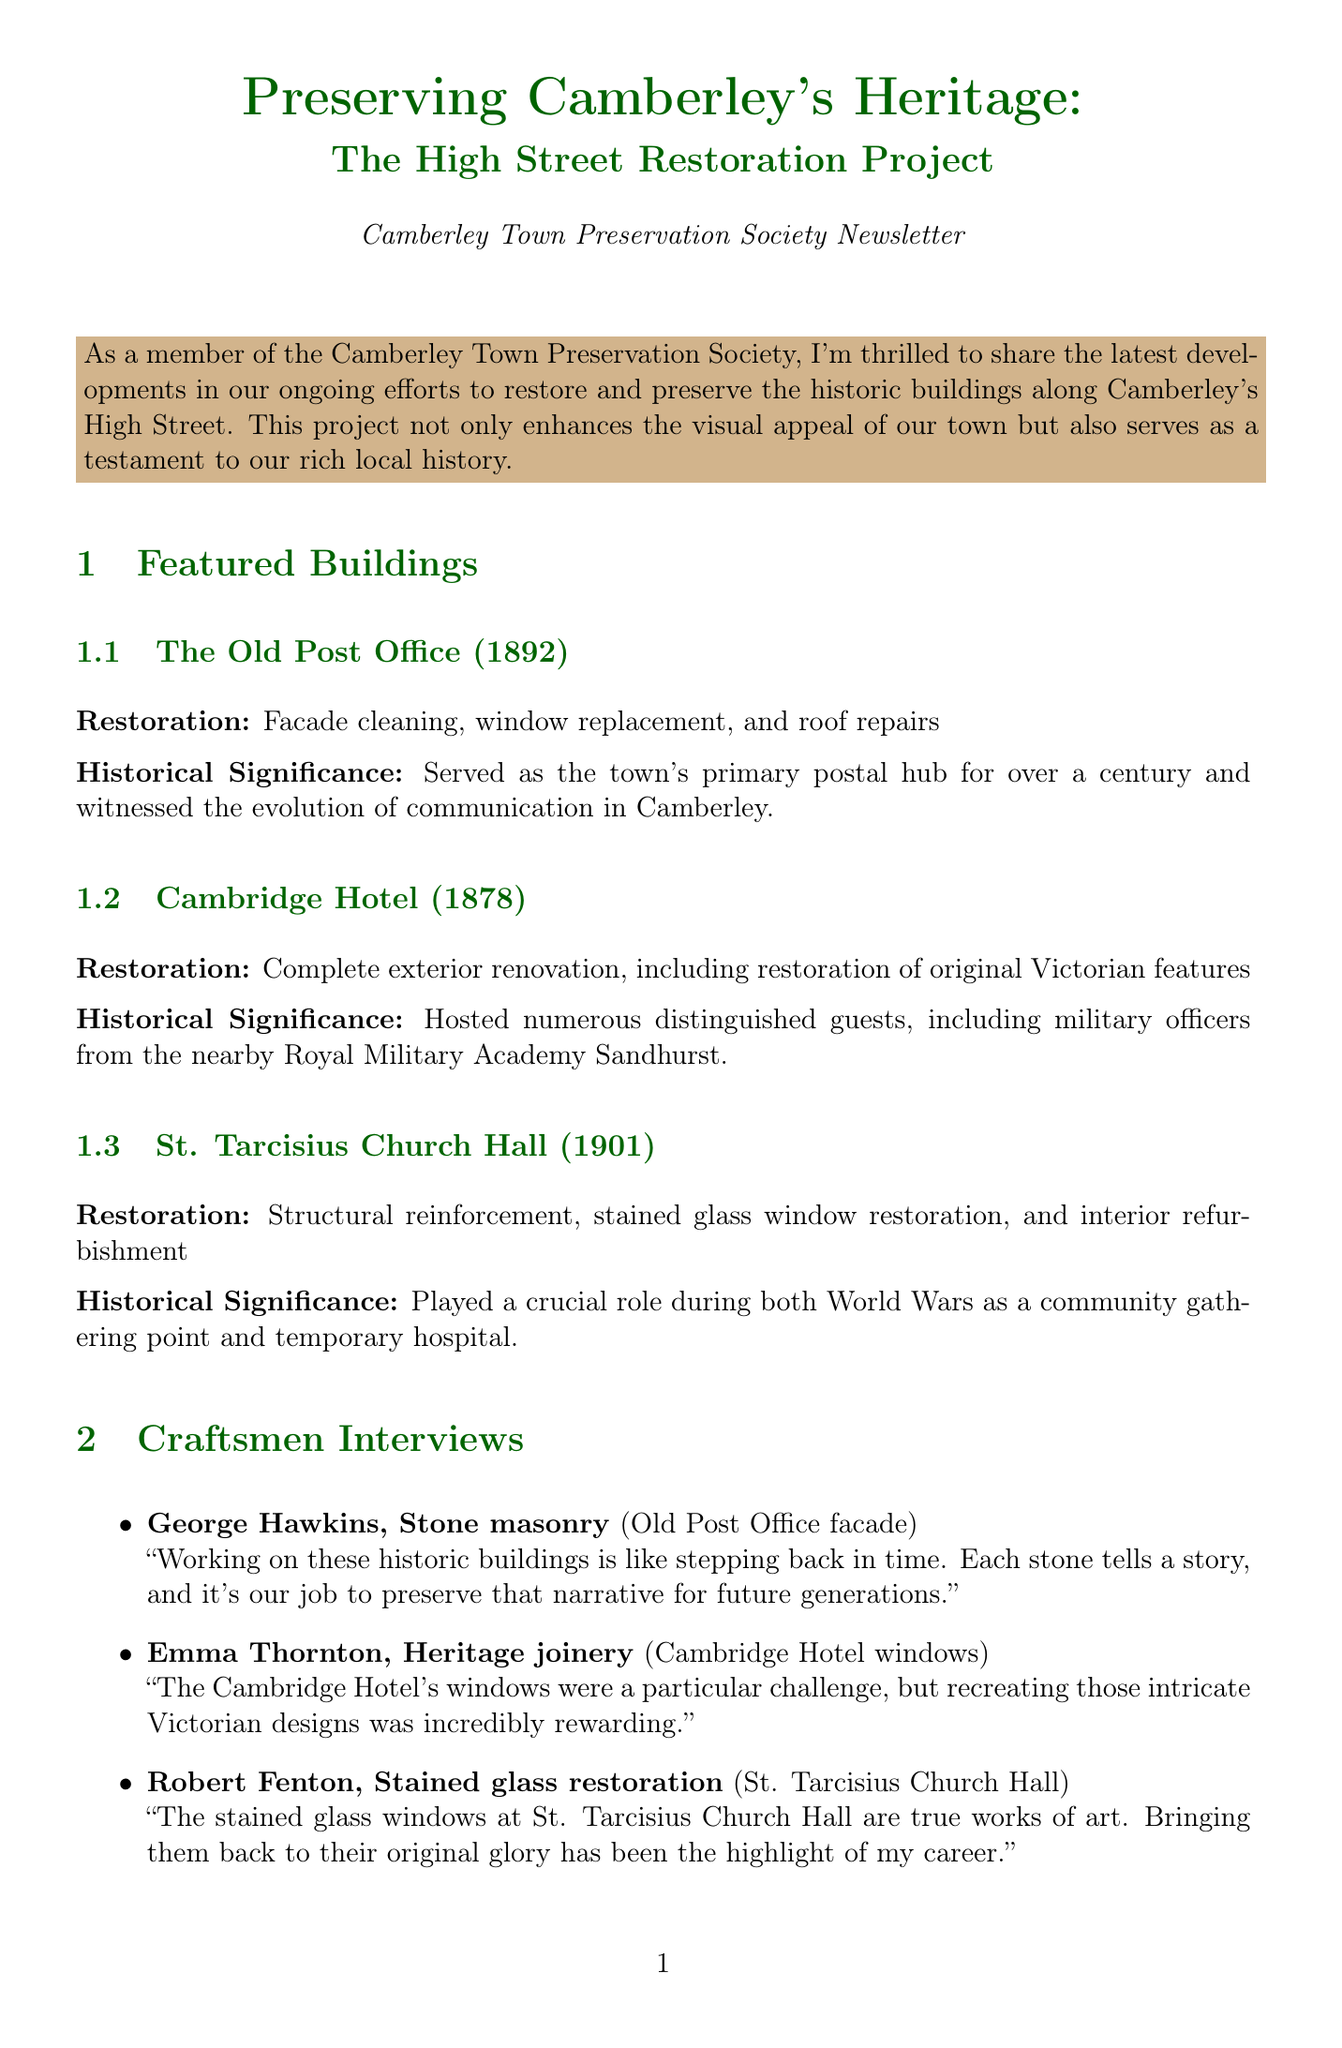what year was The Old Post Office constructed? The document states that The Old Post Office was constructed in 1892.
Answer: 1892 what type of restoration was done to the Cambridge Hotel? The Cambridge Hotel underwent a complete exterior renovation, including restoration of original Victorian features.
Answer: Complete exterior renovation who worked on the stained glass restoration at St. Tarcisius Church Hall? The craftsman mentioned for stained glass restoration at St. Tarcisius Church Hall is Robert Fenton.
Answer: Robert Fenton what percentage increase in tourism has Camberley seen since the project began? The document indicates a 15% increase in tourism.
Answer: 15% which building served as the town's primary postal hub? The Old Post Office is described as the town's primary postal hub.
Answer: The Old Post Office what were the specific restoration details for St. Tarcisius Church Hall? The restoration details for St. Tarcisius Church Hall included structural reinforcement, stained glass window restoration, and interior refurbishment.
Answer: Structural reinforcement, stained glass window restoration, and interior refurbishment how often does the Town Preservation Society meet? According to the document, the Town Preservation Society meets every second Tuesday.
Answer: Every second Tuesday what future plan involves teaching young people? The document mentions a workshop series teaching traditional building techniques to local youth as a future plan.
Answer: Workshop series teaching traditional building techniques to local youth who quotes about working on the Old Post Office facade? George Hawkins quotes about his work on the Old Post Office facade in the document.
Answer: George Hawkins 